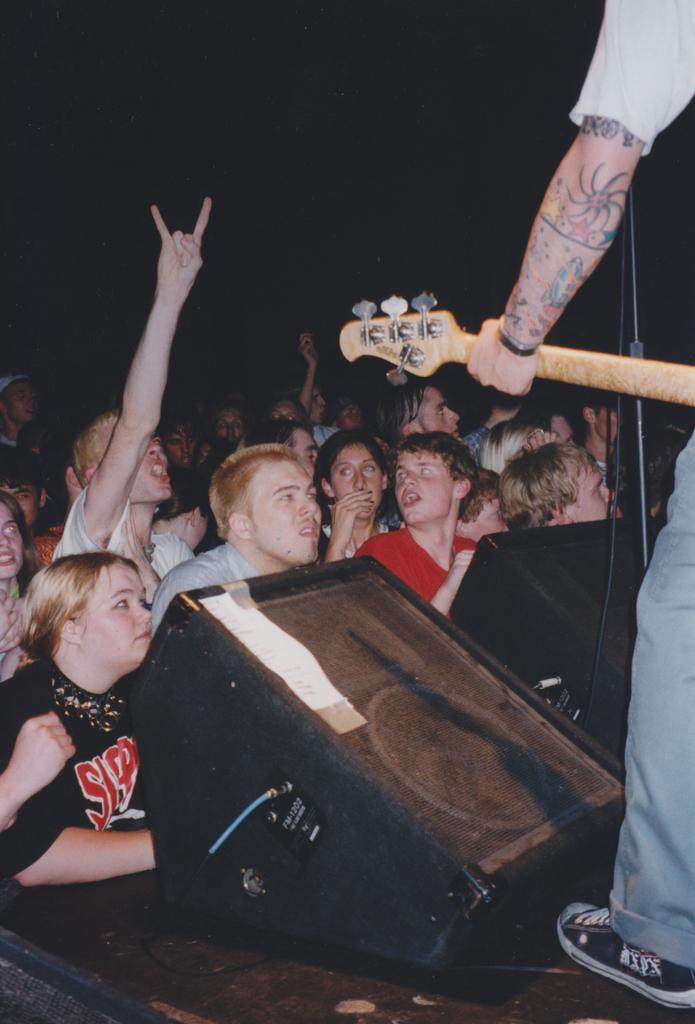How many people are in the image? There is a group of persons standing in the image. What is the man holding in the image? The man is holding a guitar in the image. What object is present for amplifying sound? There is a microphone in the image. What is the purpose of the stand in the image? There is a stand in the image, which might be used to hold the guitar or other equipment. What type of material is visible in the image? There is a wire in the image, which is likely used for connecting or supporting equipment. What type of drum can be seen being sorted in the image? There is no drum present in the image, nor is there any indication of sorting or balancing activities. 